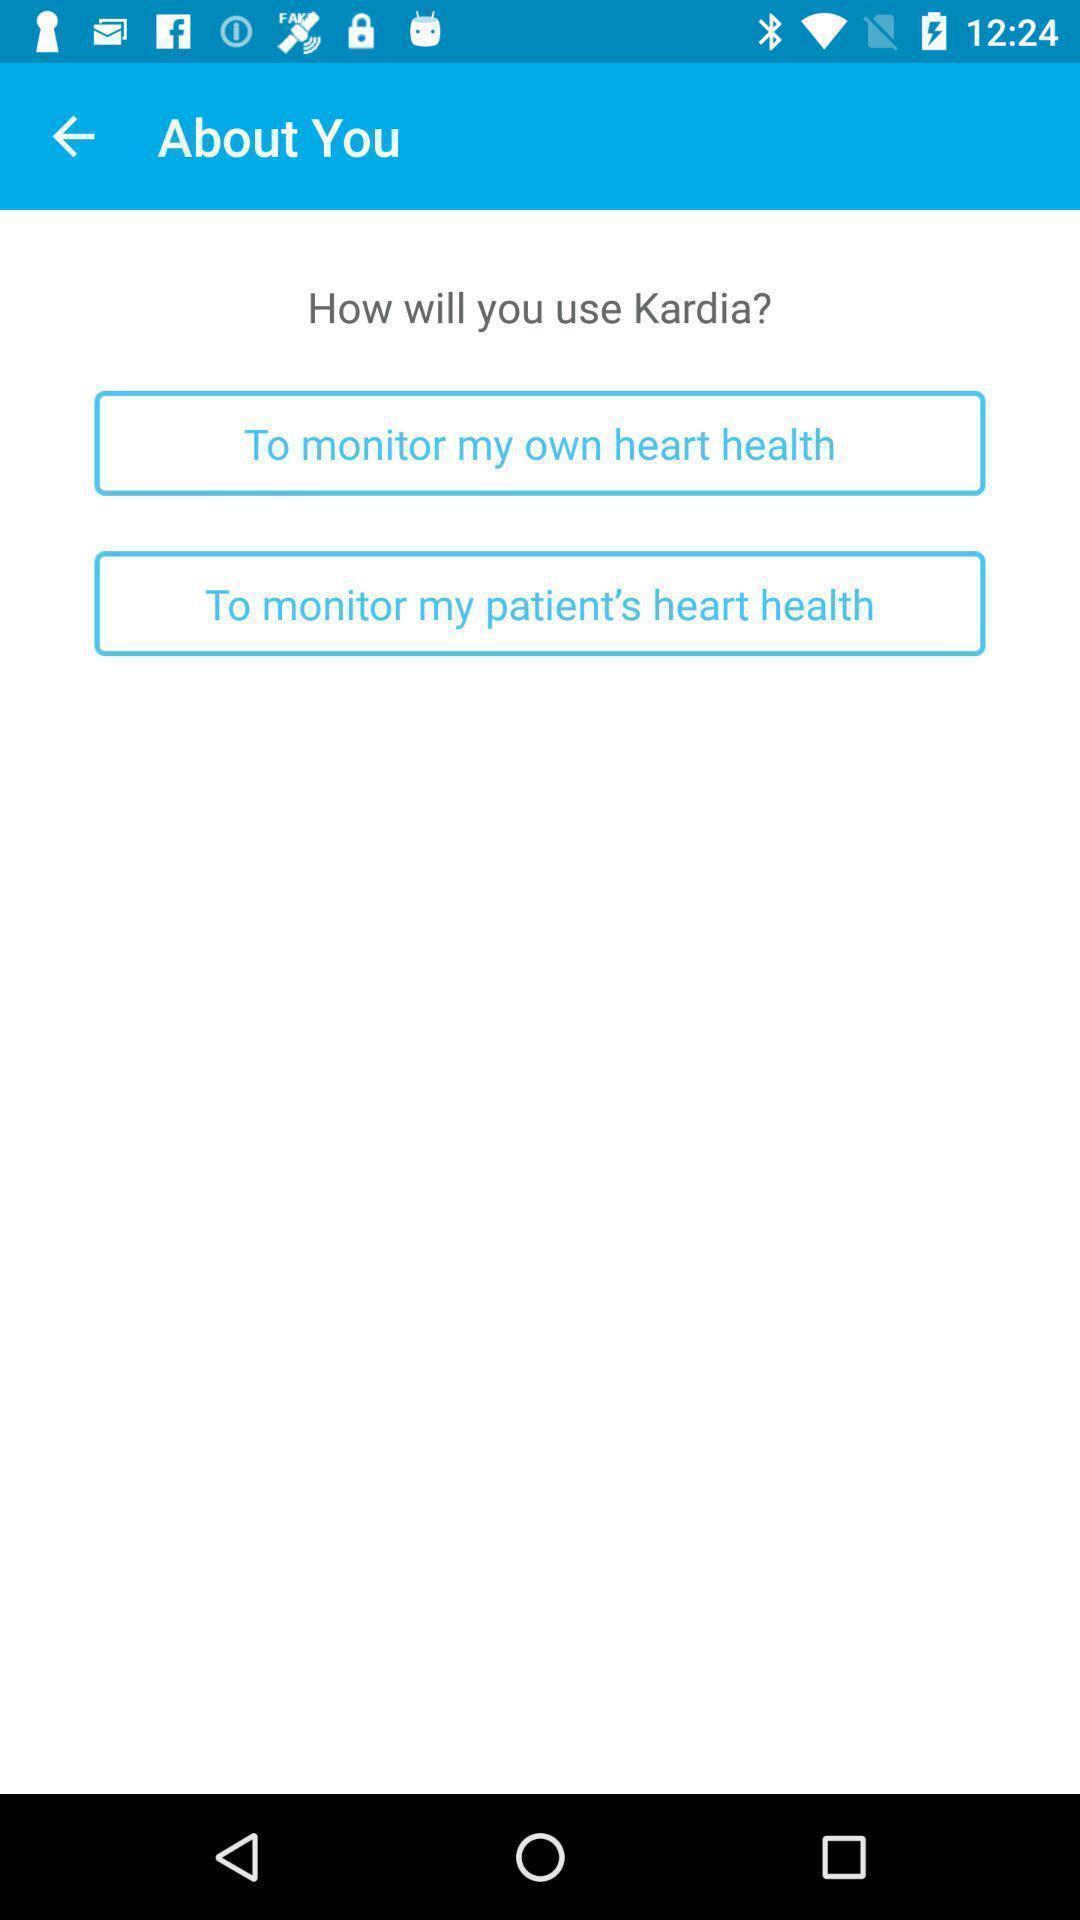Summarize the main components in this picture. Page displaying the information about the heart. 